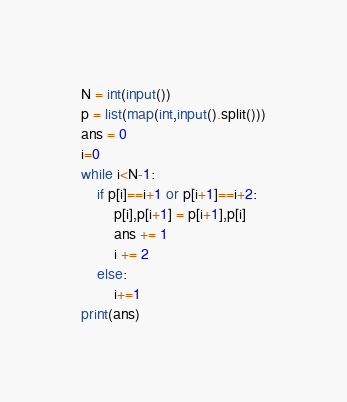Convert code to text. <code><loc_0><loc_0><loc_500><loc_500><_Python_>N = int(input())
p = list(map(int,input().split()))
ans = 0
i=0
while i<N-1:
    if p[i]==i+1 or p[i+1]==i+2:
        p[i],p[i+1] = p[i+1],p[i]
        ans += 1
        i += 2
    else:
        i+=1
print(ans)</code> 